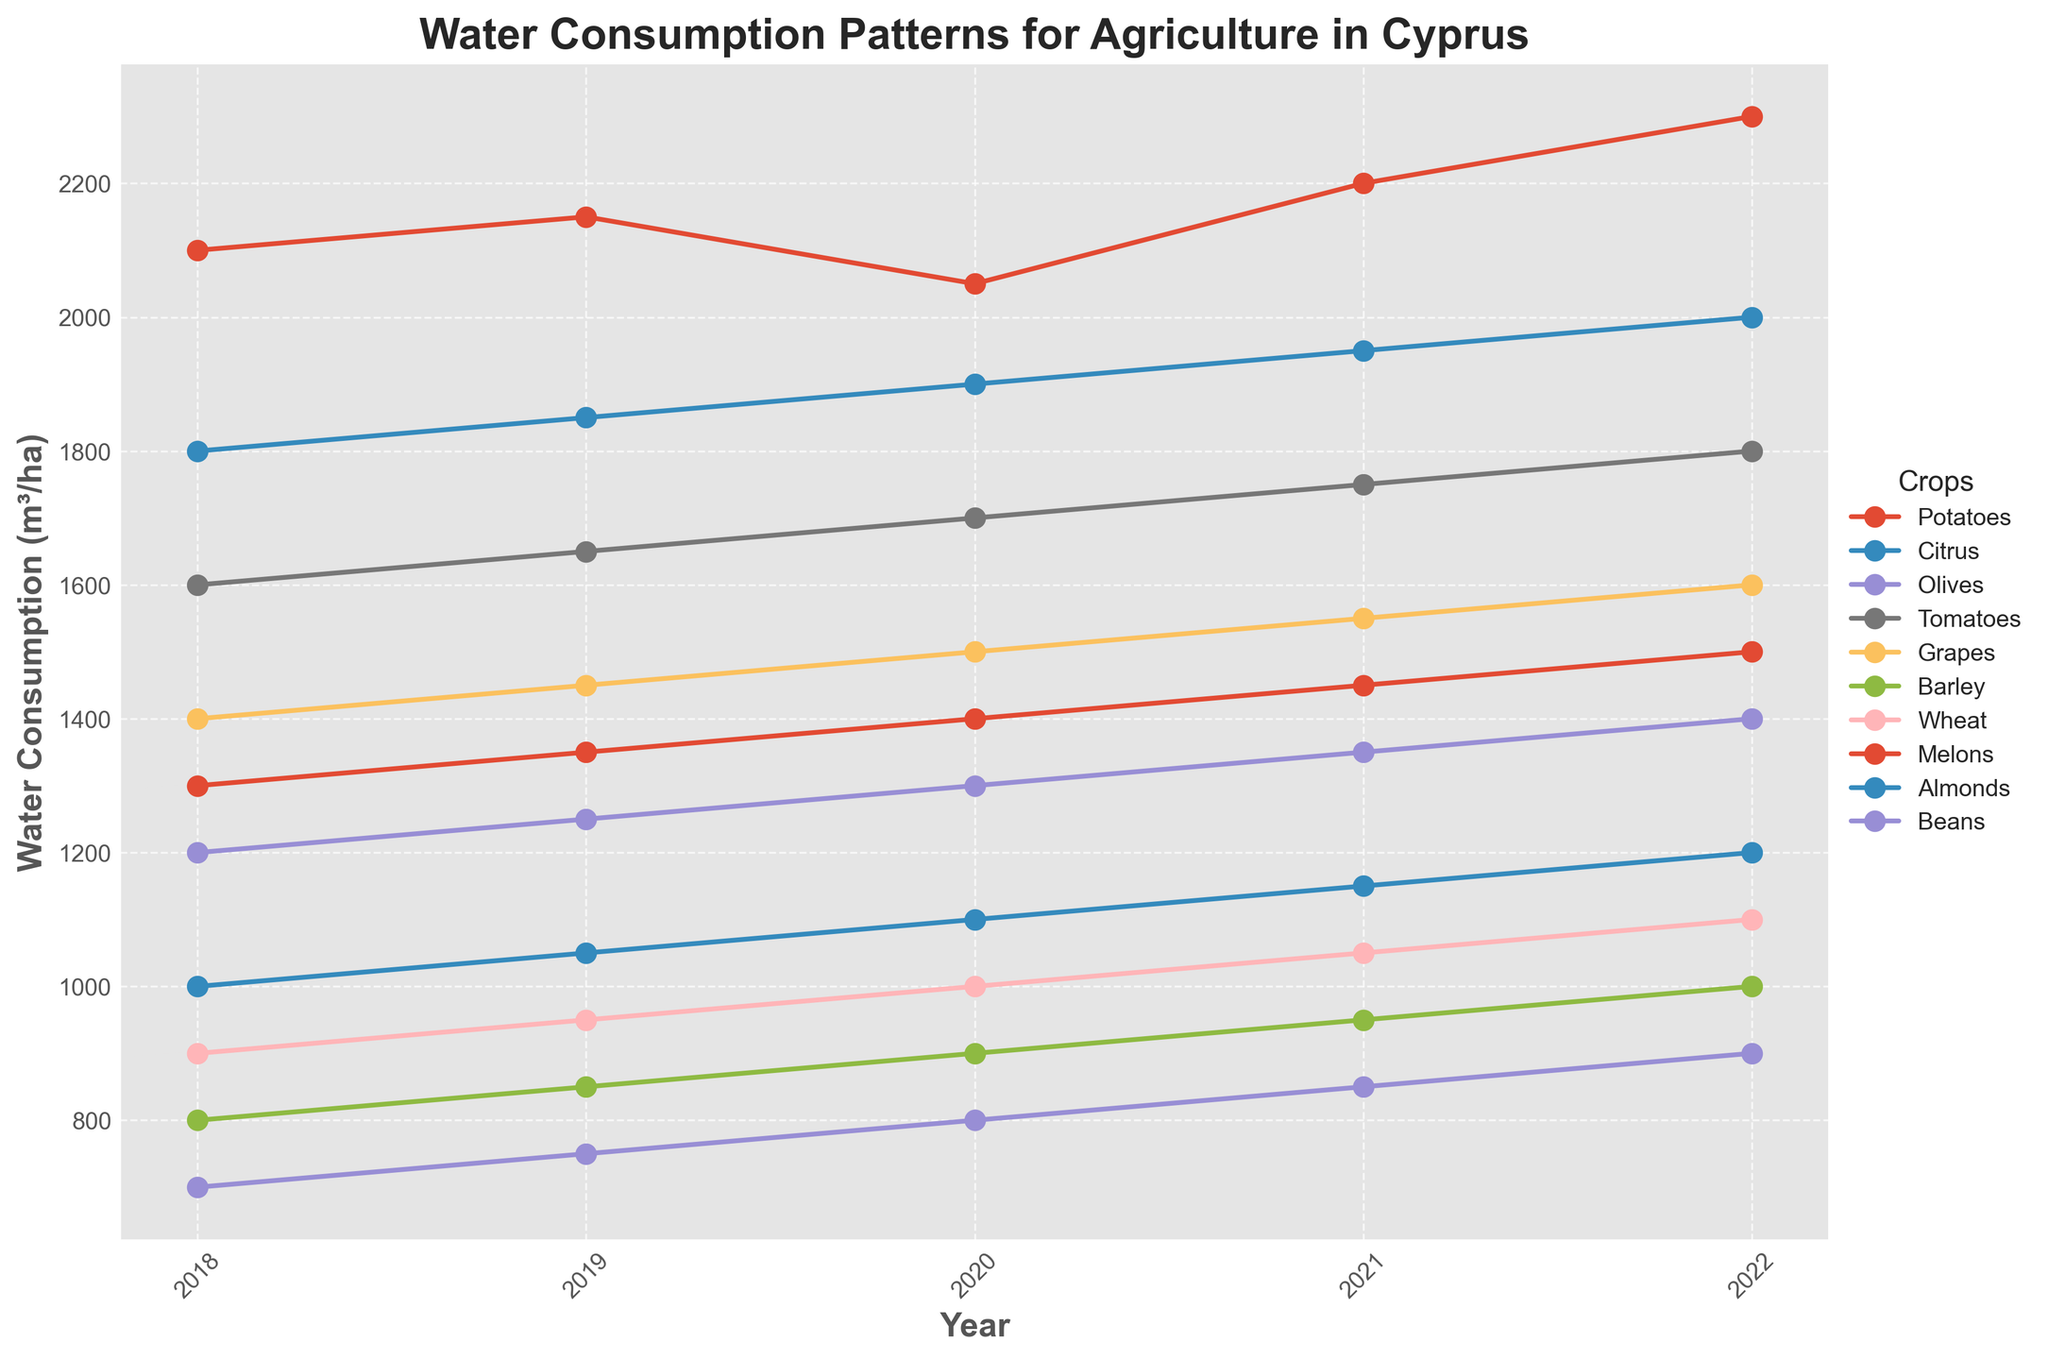What's the trend in water consumption for potatoes from 2018 to 2022? The plot shows a line for each crop, and we can observe the trend for potatoes by looking at its line. The line for potatoes starts at 2100 m³/ha in 2018 and increases each year, reaching 2300 m³/ha in 2022.
Answer: Increasing Which crop has the lowest water consumption in 2022? We look at the rightmost points of the lines for each crop in 2022. The line for beans is the lowest, indicating it has the lowest water consumption at 900 m³/ha.
Answer: Beans Compare water consumption of citrus and olives in 2020. Which is higher and by how much? In 2020, the points for citrus and olives can be compared directly. The water consumption for citrus is 1900 m³/ha, and for olives, it is 1300 m³/ha. The difference is calculated as 1900 - 1300 = 600 m³/ha.
Answer: Citrus, by 600 m³/ha What was the average water consumption for tomatoes between 2018 and 2022? To find the average, sum the water consumption values for tomatoes from 2018 to 2022 and divide by the number of years: (1600 + 1650 + 1700 + 1750 + 1800) / 5. The total sum is 8500, so the average is 8500 / 5 = 1700 m³/ha.
Answer: 1700 m³/ha Which crop had the most significant increase in water consumption from 2018 to 2022? The increase is the difference between water consumption in 2022 and 2018. Calculate this for each crop and identify the highest. For potatoes, it's 2300 - 2100 = 200; citrus, 2000 - 1800 = 200; olives, 1400 - 1200 = 200; tomatoes, 1800 - 1600 = 200; grapes, 1600 - 1400 = 200; barley, 1000 - 800 = 200; wheat, 1100 - 900 = 200; melons, 1500 - 1300 = 200; almonds, 1200 - 1000 = 200; beans, 900 - 700 = 200. All crops have the same increase of 200 m³/ha.
Answer: All crops, 200 m³/ha What is the total water consumption for potatoes and tomatoes in 2019? Sum the water consumption for potatoes and tomatoes in 2019: Potatoes (2150) + Tomatoes (1650). The total is 2150 + 1650 = 3800 m³/ha.
Answer: 3800 m³/ha Which crops had an average water consumption greater than 1500 m³/ha from 2018 to 2022? Calculate the average for each crop and compare: Potatoes (2160), Citrus (1900), Olives (1300), Tomatoes (1700), Grapes (1500), Barley (900), Wheat (1000), Melons (1400), Almonds (1100), Beans (800). The crops with averages greater than 1500 are Potatoes, Citrus, and Tomatoes.
Answer: Potatoes, Citrus, Tomatoes How did the water consumption for barley change between 2020 and 2021? Look at the values for barley in 2020 (900) and 2021 (950). The change is 950 - 900 = 50 m³/ha, which is an increase.
Answer: Increased by 50 m³/ha In which years did almonds' water consumption increase by exactly 50 m³/ha compared to the previous year? Observe the sequential year's data for almonds: 2018 (1000), 2019 (1050), 2020 (1100), 2021 (1150), 2022 (1200). The increments are 50 m³/ha each year.
Answer: 2019, 2020, 2021, 2022 